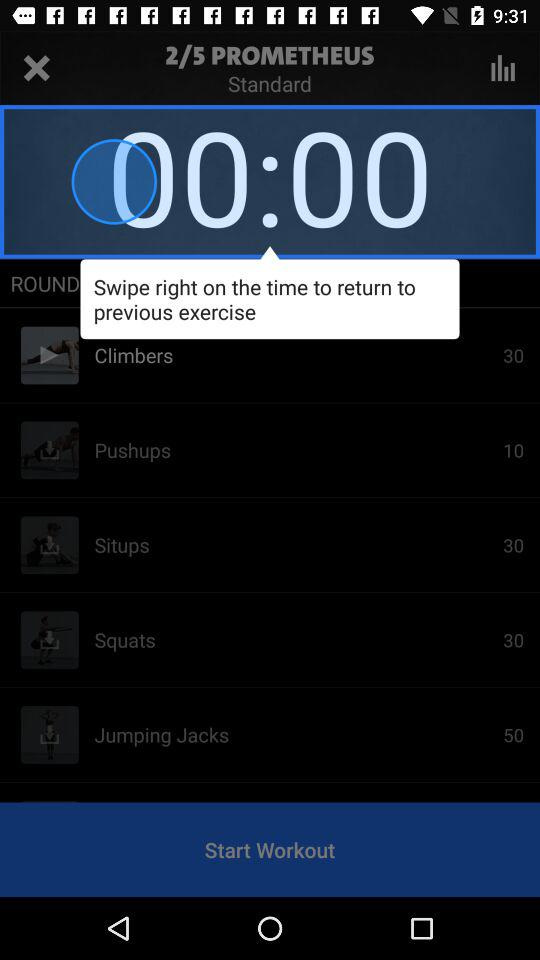How many exercises are there in the workout?
Answer the question using a single word or phrase. 5 